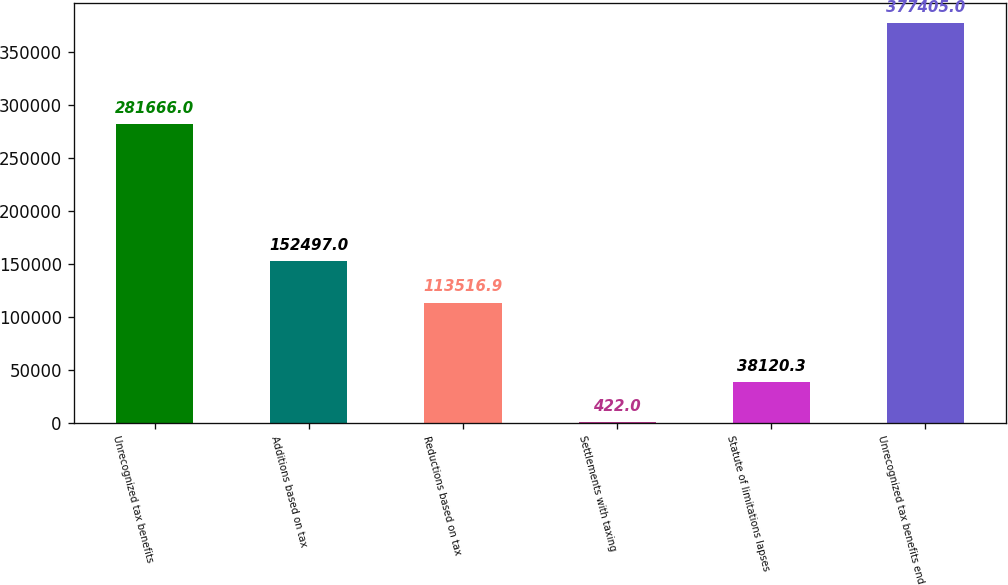<chart> <loc_0><loc_0><loc_500><loc_500><bar_chart><fcel>Unrecognized tax benefits<fcel>Additions based on tax<fcel>Reductions based on tax<fcel>Settlements with taxing<fcel>Statute of limitations lapses<fcel>Unrecognized tax benefits end<nl><fcel>281666<fcel>152497<fcel>113517<fcel>422<fcel>38120.3<fcel>377405<nl></chart> 